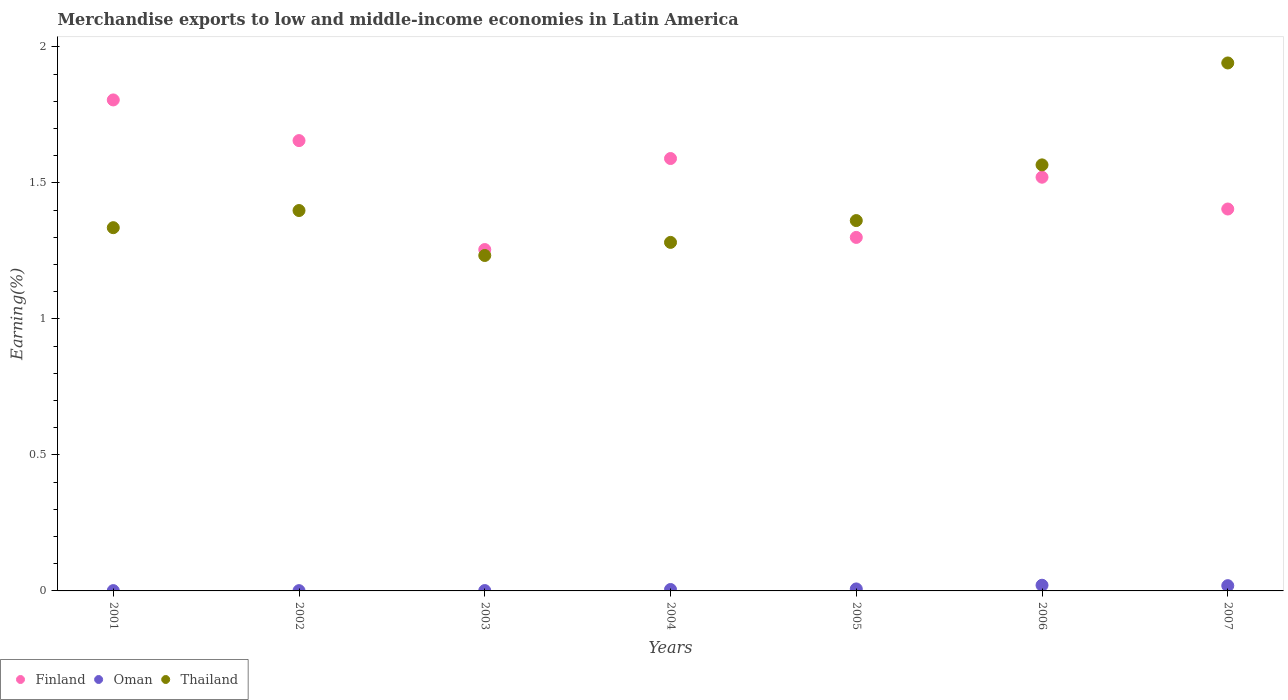How many different coloured dotlines are there?
Your answer should be very brief. 3. Is the number of dotlines equal to the number of legend labels?
Ensure brevity in your answer.  Yes. What is the percentage of amount earned from merchandise exports in Thailand in 2005?
Offer a terse response. 1.36. Across all years, what is the maximum percentage of amount earned from merchandise exports in Oman?
Offer a very short reply. 0.02. Across all years, what is the minimum percentage of amount earned from merchandise exports in Oman?
Offer a very short reply. 0. In which year was the percentage of amount earned from merchandise exports in Finland minimum?
Provide a succinct answer. 2003. What is the total percentage of amount earned from merchandise exports in Oman in the graph?
Your answer should be compact. 0.06. What is the difference between the percentage of amount earned from merchandise exports in Oman in 2002 and that in 2003?
Keep it short and to the point. -0. What is the difference between the percentage of amount earned from merchandise exports in Finland in 2006 and the percentage of amount earned from merchandise exports in Thailand in 2003?
Offer a very short reply. 0.29. What is the average percentage of amount earned from merchandise exports in Thailand per year?
Offer a terse response. 1.45. In the year 2001, what is the difference between the percentage of amount earned from merchandise exports in Thailand and percentage of amount earned from merchandise exports in Oman?
Make the answer very short. 1.33. What is the ratio of the percentage of amount earned from merchandise exports in Finland in 2001 to that in 2006?
Offer a very short reply. 1.19. What is the difference between the highest and the second highest percentage of amount earned from merchandise exports in Oman?
Give a very brief answer. 0. What is the difference between the highest and the lowest percentage of amount earned from merchandise exports in Thailand?
Your response must be concise. 0.71. Is it the case that in every year, the sum of the percentage of amount earned from merchandise exports in Oman and percentage of amount earned from merchandise exports in Finland  is greater than the percentage of amount earned from merchandise exports in Thailand?
Your response must be concise. No. How many dotlines are there?
Give a very brief answer. 3. How many years are there in the graph?
Give a very brief answer. 7. Does the graph contain any zero values?
Make the answer very short. No. How many legend labels are there?
Your response must be concise. 3. What is the title of the graph?
Keep it short and to the point. Merchandise exports to low and middle-income economies in Latin America. Does "United Kingdom" appear as one of the legend labels in the graph?
Make the answer very short. No. What is the label or title of the Y-axis?
Keep it short and to the point. Earning(%). What is the Earning(%) in Finland in 2001?
Ensure brevity in your answer.  1.8. What is the Earning(%) of Oman in 2001?
Offer a terse response. 0. What is the Earning(%) of Thailand in 2001?
Your answer should be compact. 1.34. What is the Earning(%) in Finland in 2002?
Provide a short and direct response. 1.66. What is the Earning(%) of Oman in 2002?
Offer a terse response. 0. What is the Earning(%) in Thailand in 2002?
Offer a terse response. 1.4. What is the Earning(%) in Finland in 2003?
Provide a short and direct response. 1.25. What is the Earning(%) of Oman in 2003?
Ensure brevity in your answer.  0. What is the Earning(%) in Thailand in 2003?
Offer a very short reply. 1.23. What is the Earning(%) of Finland in 2004?
Your answer should be compact. 1.59. What is the Earning(%) in Oman in 2004?
Your answer should be very brief. 0.01. What is the Earning(%) of Thailand in 2004?
Your response must be concise. 1.28. What is the Earning(%) in Finland in 2005?
Keep it short and to the point. 1.3. What is the Earning(%) in Oman in 2005?
Give a very brief answer. 0.01. What is the Earning(%) of Thailand in 2005?
Your answer should be compact. 1.36. What is the Earning(%) in Finland in 2006?
Offer a very short reply. 1.52. What is the Earning(%) in Oman in 2006?
Your response must be concise. 0.02. What is the Earning(%) of Thailand in 2006?
Offer a very short reply. 1.57. What is the Earning(%) in Finland in 2007?
Provide a short and direct response. 1.4. What is the Earning(%) of Oman in 2007?
Ensure brevity in your answer.  0.02. What is the Earning(%) of Thailand in 2007?
Your response must be concise. 1.94. Across all years, what is the maximum Earning(%) in Finland?
Offer a terse response. 1.8. Across all years, what is the maximum Earning(%) in Oman?
Make the answer very short. 0.02. Across all years, what is the maximum Earning(%) in Thailand?
Provide a succinct answer. 1.94. Across all years, what is the minimum Earning(%) of Finland?
Make the answer very short. 1.25. Across all years, what is the minimum Earning(%) in Oman?
Your response must be concise. 0. Across all years, what is the minimum Earning(%) of Thailand?
Keep it short and to the point. 1.23. What is the total Earning(%) of Finland in the graph?
Your answer should be compact. 10.53. What is the total Earning(%) in Oman in the graph?
Your answer should be very brief. 0.06. What is the total Earning(%) of Thailand in the graph?
Provide a short and direct response. 10.12. What is the difference between the Earning(%) in Finland in 2001 and that in 2002?
Offer a terse response. 0.15. What is the difference between the Earning(%) in Thailand in 2001 and that in 2002?
Provide a short and direct response. -0.06. What is the difference between the Earning(%) of Finland in 2001 and that in 2003?
Give a very brief answer. 0.55. What is the difference between the Earning(%) of Oman in 2001 and that in 2003?
Your response must be concise. -0. What is the difference between the Earning(%) of Thailand in 2001 and that in 2003?
Provide a short and direct response. 0.1. What is the difference between the Earning(%) of Finland in 2001 and that in 2004?
Your answer should be very brief. 0.22. What is the difference between the Earning(%) in Oman in 2001 and that in 2004?
Your answer should be very brief. -0. What is the difference between the Earning(%) of Thailand in 2001 and that in 2004?
Keep it short and to the point. 0.05. What is the difference between the Earning(%) in Finland in 2001 and that in 2005?
Offer a terse response. 0.51. What is the difference between the Earning(%) of Oman in 2001 and that in 2005?
Provide a succinct answer. -0.01. What is the difference between the Earning(%) of Thailand in 2001 and that in 2005?
Provide a succinct answer. -0.03. What is the difference between the Earning(%) of Finland in 2001 and that in 2006?
Your response must be concise. 0.28. What is the difference between the Earning(%) of Oman in 2001 and that in 2006?
Your answer should be very brief. -0.02. What is the difference between the Earning(%) of Thailand in 2001 and that in 2006?
Your answer should be very brief. -0.23. What is the difference between the Earning(%) of Finland in 2001 and that in 2007?
Ensure brevity in your answer.  0.4. What is the difference between the Earning(%) of Oman in 2001 and that in 2007?
Ensure brevity in your answer.  -0.02. What is the difference between the Earning(%) in Thailand in 2001 and that in 2007?
Give a very brief answer. -0.61. What is the difference between the Earning(%) in Finland in 2002 and that in 2003?
Your response must be concise. 0.4. What is the difference between the Earning(%) of Oman in 2002 and that in 2003?
Make the answer very short. -0. What is the difference between the Earning(%) in Thailand in 2002 and that in 2003?
Provide a succinct answer. 0.17. What is the difference between the Earning(%) in Finland in 2002 and that in 2004?
Your answer should be compact. 0.07. What is the difference between the Earning(%) of Oman in 2002 and that in 2004?
Provide a short and direct response. -0. What is the difference between the Earning(%) of Thailand in 2002 and that in 2004?
Offer a very short reply. 0.12. What is the difference between the Earning(%) in Finland in 2002 and that in 2005?
Your response must be concise. 0.36. What is the difference between the Earning(%) of Oman in 2002 and that in 2005?
Offer a very short reply. -0.01. What is the difference between the Earning(%) of Thailand in 2002 and that in 2005?
Your answer should be compact. 0.04. What is the difference between the Earning(%) of Finland in 2002 and that in 2006?
Ensure brevity in your answer.  0.13. What is the difference between the Earning(%) in Oman in 2002 and that in 2006?
Offer a terse response. -0.02. What is the difference between the Earning(%) of Thailand in 2002 and that in 2006?
Offer a very short reply. -0.17. What is the difference between the Earning(%) of Finland in 2002 and that in 2007?
Offer a very short reply. 0.25. What is the difference between the Earning(%) of Oman in 2002 and that in 2007?
Ensure brevity in your answer.  -0.02. What is the difference between the Earning(%) of Thailand in 2002 and that in 2007?
Offer a very short reply. -0.54. What is the difference between the Earning(%) in Finland in 2003 and that in 2004?
Ensure brevity in your answer.  -0.33. What is the difference between the Earning(%) of Oman in 2003 and that in 2004?
Your answer should be compact. -0. What is the difference between the Earning(%) in Thailand in 2003 and that in 2004?
Your answer should be compact. -0.05. What is the difference between the Earning(%) in Finland in 2003 and that in 2005?
Ensure brevity in your answer.  -0.04. What is the difference between the Earning(%) of Oman in 2003 and that in 2005?
Your answer should be compact. -0.01. What is the difference between the Earning(%) in Thailand in 2003 and that in 2005?
Give a very brief answer. -0.13. What is the difference between the Earning(%) in Finland in 2003 and that in 2006?
Keep it short and to the point. -0.27. What is the difference between the Earning(%) of Oman in 2003 and that in 2006?
Your answer should be compact. -0.02. What is the difference between the Earning(%) of Thailand in 2003 and that in 2006?
Provide a succinct answer. -0.33. What is the difference between the Earning(%) of Finland in 2003 and that in 2007?
Keep it short and to the point. -0.15. What is the difference between the Earning(%) in Oman in 2003 and that in 2007?
Your answer should be compact. -0.02. What is the difference between the Earning(%) in Thailand in 2003 and that in 2007?
Offer a terse response. -0.71. What is the difference between the Earning(%) of Finland in 2004 and that in 2005?
Your answer should be compact. 0.29. What is the difference between the Earning(%) in Oman in 2004 and that in 2005?
Offer a terse response. -0. What is the difference between the Earning(%) in Thailand in 2004 and that in 2005?
Your response must be concise. -0.08. What is the difference between the Earning(%) of Finland in 2004 and that in 2006?
Provide a short and direct response. 0.07. What is the difference between the Earning(%) in Oman in 2004 and that in 2006?
Your response must be concise. -0.02. What is the difference between the Earning(%) of Thailand in 2004 and that in 2006?
Offer a terse response. -0.28. What is the difference between the Earning(%) of Finland in 2004 and that in 2007?
Your answer should be compact. 0.19. What is the difference between the Earning(%) of Oman in 2004 and that in 2007?
Provide a short and direct response. -0.01. What is the difference between the Earning(%) in Thailand in 2004 and that in 2007?
Your answer should be very brief. -0.66. What is the difference between the Earning(%) in Finland in 2005 and that in 2006?
Give a very brief answer. -0.22. What is the difference between the Earning(%) in Oman in 2005 and that in 2006?
Ensure brevity in your answer.  -0.01. What is the difference between the Earning(%) of Thailand in 2005 and that in 2006?
Ensure brevity in your answer.  -0.2. What is the difference between the Earning(%) of Finland in 2005 and that in 2007?
Give a very brief answer. -0.1. What is the difference between the Earning(%) of Oman in 2005 and that in 2007?
Offer a terse response. -0.01. What is the difference between the Earning(%) of Thailand in 2005 and that in 2007?
Offer a very short reply. -0.58. What is the difference between the Earning(%) of Finland in 2006 and that in 2007?
Offer a very short reply. 0.12. What is the difference between the Earning(%) in Oman in 2006 and that in 2007?
Offer a terse response. 0. What is the difference between the Earning(%) of Thailand in 2006 and that in 2007?
Provide a succinct answer. -0.37. What is the difference between the Earning(%) of Finland in 2001 and the Earning(%) of Oman in 2002?
Your response must be concise. 1.8. What is the difference between the Earning(%) in Finland in 2001 and the Earning(%) in Thailand in 2002?
Give a very brief answer. 0.41. What is the difference between the Earning(%) of Oman in 2001 and the Earning(%) of Thailand in 2002?
Your response must be concise. -1.4. What is the difference between the Earning(%) in Finland in 2001 and the Earning(%) in Oman in 2003?
Keep it short and to the point. 1.8. What is the difference between the Earning(%) in Finland in 2001 and the Earning(%) in Thailand in 2003?
Offer a terse response. 0.57. What is the difference between the Earning(%) in Oman in 2001 and the Earning(%) in Thailand in 2003?
Keep it short and to the point. -1.23. What is the difference between the Earning(%) of Finland in 2001 and the Earning(%) of Oman in 2004?
Offer a very short reply. 1.8. What is the difference between the Earning(%) of Finland in 2001 and the Earning(%) of Thailand in 2004?
Ensure brevity in your answer.  0.52. What is the difference between the Earning(%) of Oman in 2001 and the Earning(%) of Thailand in 2004?
Your answer should be compact. -1.28. What is the difference between the Earning(%) of Finland in 2001 and the Earning(%) of Oman in 2005?
Your answer should be compact. 1.8. What is the difference between the Earning(%) in Finland in 2001 and the Earning(%) in Thailand in 2005?
Give a very brief answer. 0.44. What is the difference between the Earning(%) in Oman in 2001 and the Earning(%) in Thailand in 2005?
Offer a very short reply. -1.36. What is the difference between the Earning(%) in Finland in 2001 and the Earning(%) in Oman in 2006?
Keep it short and to the point. 1.78. What is the difference between the Earning(%) of Finland in 2001 and the Earning(%) of Thailand in 2006?
Keep it short and to the point. 0.24. What is the difference between the Earning(%) in Oman in 2001 and the Earning(%) in Thailand in 2006?
Ensure brevity in your answer.  -1.56. What is the difference between the Earning(%) in Finland in 2001 and the Earning(%) in Oman in 2007?
Your response must be concise. 1.79. What is the difference between the Earning(%) of Finland in 2001 and the Earning(%) of Thailand in 2007?
Ensure brevity in your answer.  -0.14. What is the difference between the Earning(%) in Oman in 2001 and the Earning(%) in Thailand in 2007?
Offer a very short reply. -1.94. What is the difference between the Earning(%) of Finland in 2002 and the Earning(%) of Oman in 2003?
Offer a very short reply. 1.65. What is the difference between the Earning(%) of Finland in 2002 and the Earning(%) of Thailand in 2003?
Your answer should be compact. 0.42. What is the difference between the Earning(%) in Oman in 2002 and the Earning(%) in Thailand in 2003?
Offer a terse response. -1.23. What is the difference between the Earning(%) of Finland in 2002 and the Earning(%) of Oman in 2004?
Your answer should be very brief. 1.65. What is the difference between the Earning(%) of Finland in 2002 and the Earning(%) of Thailand in 2004?
Offer a very short reply. 0.37. What is the difference between the Earning(%) in Oman in 2002 and the Earning(%) in Thailand in 2004?
Offer a terse response. -1.28. What is the difference between the Earning(%) of Finland in 2002 and the Earning(%) of Oman in 2005?
Give a very brief answer. 1.65. What is the difference between the Earning(%) of Finland in 2002 and the Earning(%) of Thailand in 2005?
Offer a terse response. 0.29. What is the difference between the Earning(%) of Oman in 2002 and the Earning(%) of Thailand in 2005?
Your answer should be compact. -1.36. What is the difference between the Earning(%) in Finland in 2002 and the Earning(%) in Oman in 2006?
Provide a short and direct response. 1.63. What is the difference between the Earning(%) in Finland in 2002 and the Earning(%) in Thailand in 2006?
Your response must be concise. 0.09. What is the difference between the Earning(%) of Oman in 2002 and the Earning(%) of Thailand in 2006?
Your response must be concise. -1.56. What is the difference between the Earning(%) in Finland in 2002 and the Earning(%) in Oman in 2007?
Your answer should be compact. 1.64. What is the difference between the Earning(%) of Finland in 2002 and the Earning(%) of Thailand in 2007?
Ensure brevity in your answer.  -0.29. What is the difference between the Earning(%) of Oman in 2002 and the Earning(%) of Thailand in 2007?
Ensure brevity in your answer.  -1.94. What is the difference between the Earning(%) in Finland in 2003 and the Earning(%) in Oman in 2004?
Your response must be concise. 1.25. What is the difference between the Earning(%) of Finland in 2003 and the Earning(%) of Thailand in 2004?
Provide a succinct answer. -0.03. What is the difference between the Earning(%) of Oman in 2003 and the Earning(%) of Thailand in 2004?
Keep it short and to the point. -1.28. What is the difference between the Earning(%) of Finland in 2003 and the Earning(%) of Oman in 2005?
Your response must be concise. 1.25. What is the difference between the Earning(%) in Finland in 2003 and the Earning(%) in Thailand in 2005?
Give a very brief answer. -0.11. What is the difference between the Earning(%) in Oman in 2003 and the Earning(%) in Thailand in 2005?
Make the answer very short. -1.36. What is the difference between the Earning(%) in Finland in 2003 and the Earning(%) in Oman in 2006?
Give a very brief answer. 1.23. What is the difference between the Earning(%) of Finland in 2003 and the Earning(%) of Thailand in 2006?
Keep it short and to the point. -0.31. What is the difference between the Earning(%) of Oman in 2003 and the Earning(%) of Thailand in 2006?
Give a very brief answer. -1.56. What is the difference between the Earning(%) of Finland in 2003 and the Earning(%) of Oman in 2007?
Keep it short and to the point. 1.24. What is the difference between the Earning(%) of Finland in 2003 and the Earning(%) of Thailand in 2007?
Your response must be concise. -0.69. What is the difference between the Earning(%) of Oman in 2003 and the Earning(%) of Thailand in 2007?
Your answer should be very brief. -1.94. What is the difference between the Earning(%) in Finland in 2004 and the Earning(%) in Oman in 2005?
Offer a very short reply. 1.58. What is the difference between the Earning(%) in Finland in 2004 and the Earning(%) in Thailand in 2005?
Your answer should be compact. 0.23. What is the difference between the Earning(%) of Oman in 2004 and the Earning(%) of Thailand in 2005?
Your answer should be very brief. -1.36. What is the difference between the Earning(%) of Finland in 2004 and the Earning(%) of Oman in 2006?
Offer a terse response. 1.57. What is the difference between the Earning(%) in Finland in 2004 and the Earning(%) in Thailand in 2006?
Your answer should be very brief. 0.02. What is the difference between the Earning(%) in Oman in 2004 and the Earning(%) in Thailand in 2006?
Your answer should be compact. -1.56. What is the difference between the Earning(%) of Finland in 2004 and the Earning(%) of Oman in 2007?
Offer a very short reply. 1.57. What is the difference between the Earning(%) of Finland in 2004 and the Earning(%) of Thailand in 2007?
Offer a terse response. -0.35. What is the difference between the Earning(%) in Oman in 2004 and the Earning(%) in Thailand in 2007?
Your response must be concise. -1.94. What is the difference between the Earning(%) in Finland in 2005 and the Earning(%) in Oman in 2006?
Give a very brief answer. 1.28. What is the difference between the Earning(%) of Finland in 2005 and the Earning(%) of Thailand in 2006?
Give a very brief answer. -0.27. What is the difference between the Earning(%) in Oman in 2005 and the Earning(%) in Thailand in 2006?
Make the answer very short. -1.56. What is the difference between the Earning(%) in Finland in 2005 and the Earning(%) in Oman in 2007?
Provide a succinct answer. 1.28. What is the difference between the Earning(%) of Finland in 2005 and the Earning(%) of Thailand in 2007?
Offer a very short reply. -0.64. What is the difference between the Earning(%) in Oman in 2005 and the Earning(%) in Thailand in 2007?
Keep it short and to the point. -1.93. What is the difference between the Earning(%) of Finland in 2006 and the Earning(%) of Oman in 2007?
Keep it short and to the point. 1.5. What is the difference between the Earning(%) in Finland in 2006 and the Earning(%) in Thailand in 2007?
Keep it short and to the point. -0.42. What is the difference between the Earning(%) in Oman in 2006 and the Earning(%) in Thailand in 2007?
Ensure brevity in your answer.  -1.92. What is the average Earning(%) of Finland per year?
Your response must be concise. 1.5. What is the average Earning(%) in Oman per year?
Provide a short and direct response. 0.01. What is the average Earning(%) in Thailand per year?
Provide a succinct answer. 1.45. In the year 2001, what is the difference between the Earning(%) of Finland and Earning(%) of Oman?
Offer a very short reply. 1.8. In the year 2001, what is the difference between the Earning(%) of Finland and Earning(%) of Thailand?
Your answer should be compact. 0.47. In the year 2001, what is the difference between the Earning(%) in Oman and Earning(%) in Thailand?
Offer a terse response. -1.33. In the year 2002, what is the difference between the Earning(%) of Finland and Earning(%) of Oman?
Your answer should be very brief. 1.65. In the year 2002, what is the difference between the Earning(%) of Finland and Earning(%) of Thailand?
Your answer should be compact. 0.26. In the year 2002, what is the difference between the Earning(%) of Oman and Earning(%) of Thailand?
Your response must be concise. -1.4. In the year 2003, what is the difference between the Earning(%) of Finland and Earning(%) of Oman?
Offer a terse response. 1.25. In the year 2003, what is the difference between the Earning(%) in Finland and Earning(%) in Thailand?
Your response must be concise. 0.02. In the year 2003, what is the difference between the Earning(%) of Oman and Earning(%) of Thailand?
Your response must be concise. -1.23. In the year 2004, what is the difference between the Earning(%) in Finland and Earning(%) in Oman?
Ensure brevity in your answer.  1.58. In the year 2004, what is the difference between the Earning(%) of Finland and Earning(%) of Thailand?
Offer a terse response. 0.31. In the year 2004, what is the difference between the Earning(%) of Oman and Earning(%) of Thailand?
Give a very brief answer. -1.28. In the year 2005, what is the difference between the Earning(%) in Finland and Earning(%) in Oman?
Keep it short and to the point. 1.29. In the year 2005, what is the difference between the Earning(%) of Finland and Earning(%) of Thailand?
Your answer should be very brief. -0.06. In the year 2005, what is the difference between the Earning(%) in Oman and Earning(%) in Thailand?
Provide a succinct answer. -1.35. In the year 2006, what is the difference between the Earning(%) of Finland and Earning(%) of Oman?
Your answer should be very brief. 1.5. In the year 2006, what is the difference between the Earning(%) of Finland and Earning(%) of Thailand?
Your response must be concise. -0.05. In the year 2006, what is the difference between the Earning(%) in Oman and Earning(%) in Thailand?
Your response must be concise. -1.55. In the year 2007, what is the difference between the Earning(%) in Finland and Earning(%) in Oman?
Provide a short and direct response. 1.38. In the year 2007, what is the difference between the Earning(%) in Finland and Earning(%) in Thailand?
Your answer should be very brief. -0.54. In the year 2007, what is the difference between the Earning(%) in Oman and Earning(%) in Thailand?
Ensure brevity in your answer.  -1.92. What is the ratio of the Earning(%) of Finland in 2001 to that in 2002?
Offer a very short reply. 1.09. What is the ratio of the Earning(%) in Oman in 2001 to that in 2002?
Ensure brevity in your answer.  1.06. What is the ratio of the Earning(%) of Thailand in 2001 to that in 2002?
Make the answer very short. 0.95. What is the ratio of the Earning(%) in Finland in 2001 to that in 2003?
Make the answer very short. 1.44. What is the ratio of the Earning(%) of Oman in 2001 to that in 2003?
Keep it short and to the point. 0.84. What is the ratio of the Earning(%) in Thailand in 2001 to that in 2003?
Provide a short and direct response. 1.08. What is the ratio of the Earning(%) of Finland in 2001 to that in 2004?
Your response must be concise. 1.14. What is the ratio of the Earning(%) of Oman in 2001 to that in 2004?
Keep it short and to the point. 0.21. What is the ratio of the Earning(%) of Thailand in 2001 to that in 2004?
Provide a short and direct response. 1.04. What is the ratio of the Earning(%) of Finland in 2001 to that in 2005?
Ensure brevity in your answer.  1.39. What is the ratio of the Earning(%) of Oman in 2001 to that in 2005?
Offer a very short reply. 0.15. What is the ratio of the Earning(%) in Thailand in 2001 to that in 2005?
Offer a terse response. 0.98. What is the ratio of the Earning(%) of Finland in 2001 to that in 2006?
Provide a short and direct response. 1.19. What is the ratio of the Earning(%) of Oman in 2001 to that in 2006?
Give a very brief answer. 0.05. What is the ratio of the Earning(%) in Thailand in 2001 to that in 2006?
Give a very brief answer. 0.85. What is the ratio of the Earning(%) of Finland in 2001 to that in 2007?
Keep it short and to the point. 1.29. What is the ratio of the Earning(%) in Oman in 2001 to that in 2007?
Offer a very short reply. 0.06. What is the ratio of the Earning(%) in Thailand in 2001 to that in 2007?
Your answer should be compact. 0.69. What is the ratio of the Earning(%) of Finland in 2002 to that in 2003?
Offer a very short reply. 1.32. What is the ratio of the Earning(%) in Oman in 2002 to that in 2003?
Your response must be concise. 0.79. What is the ratio of the Earning(%) of Thailand in 2002 to that in 2003?
Provide a succinct answer. 1.13. What is the ratio of the Earning(%) of Finland in 2002 to that in 2004?
Provide a succinct answer. 1.04. What is the ratio of the Earning(%) of Thailand in 2002 to that in 2004?
Keep it short and to the point. 1.09. What is the ratio of the Earning(%) of Finland in 2002 to that in 2005?
Keep it short and to the point. 1.27. What is the ratio of the Earning(%) of Oman in 2002 to that in 2005?
Keep it short and to the point. 0.14. What is the ratio of the Earning(%) in Thailand in 2002 to that in 2005?
Give a very brief answer. 1.03. What is the ratio of the Earning(%) in Finland in 2002 to that in 2006?
Provide a succinct answer. 1.09. What is the ratio of the Earning(%) of Oman in 2002 to that in 2006?
Give a very brief answer. 0.05. What is the ratio of the Earning(%) in Thailand in 2002 to that in 2006?
Your response must be concise. 0.89. What is the ratio of the Earning(%) of Finland in 2002 to that in 2007?
Ensure brevity in your answer.  1.18. What is the ratio of the Earning(%) of Oman in 2002 to that in 2007?
Make the answer very short. 0.05. What is the ratio of the Earning(%) in Thailand in 2002 to that in 2007?
Keep it short and to the point. 0.72. What is the ratio of the Earning(%) of Finland in 2003 to that in 2004?
Ensure brevity in your answer.  0.79. What is the ratio of the Earning(%) in Oman in 2003 to that in 2004?
Ensure brevity in your answer.  0.25. What is the ratio of the Earning(%) of Thailand in 2003 to that in 2004?
Keep it short and to the point. 0.96. What is the ratio of the Earning(%) in Finland in 2003 to that in 2005?
Offer a very short reply. 0.97. What is the ratio of the Earning(%) in Oman in 2003 to that in 2005?
Offer a very short reply. 0.18. What is the ratio of the Earning(%) in Thailand in 2003 to that in 2005?
Provide a succinct answer. 0.91. What is the ratio of the Earning(%) of Finland in 2003 to that in 2006?
Your response must be concise. 0.83. What is the ratio of the Earning(%) of Oman in 2003 to that in 2006?
Your response must be concise. 0.06. What is the ratio of the Earning(%) of Thailand in 2003 to that in 2006?
Your answer should be very brief. 0.79. What is the ratio of the Earning(%) in Finland in 2003 to that in 2007?
Provide a short and direct response. 0.89. What is the ratio of the Earning(%) in Oman in 2003 to that in 2007?
Offer a very short reply. 0.07. What is the ratio of the Earning(%) in Thailand in 2003 to that in 2007?
Your answer should be compact. 0.64. What is the ratio of the Earning(%) of Finland in 2004 to that in 2005?
Make the answer very short. 1.22. What is the ratio of the Earning(%) of Oman in 2004 to that in 2005?
Offer a terse response. 0.71. What is the ratio of the Earning(%) in Thailand in 2004 to that in 2005?
Make the answer very short. 0.94. What is the ratio of the Earning(%) of Finland in 2004 to that in 2006?
Your answer should be very brief. 1.05. What is the ratio of the Earning(%) of Oman in 2004 to that in 2006?
Offer a terse response. 0.25. What is the ratio of the Earning(%) in Thailand in 2004 to that in 2006?
Ensure brevity in your answer.  0.82. What is the ratio of the Earning(%) in Finland in 2004 to that in 2007?
Provide a short and direct response. 1.13. What is the ratio of the Earning(%) in Oman in 2004 to that in 2007?
Provide a short and direct response. 0.27. What is the ratio of the Earning(%) of Thailand in 2004 to that in 2007?
Provide a succinct answer. 0.66. What is the ratio of the Earning(%) of Finland in 2005 to that in 2006?
Your answer should be compact. 0.85. What is the ratio of the Earning(%) of Oman in 2005 to that in 2006?
Make the answer very short. 0.35. What is the ratio of the Earning(%) of Thailand in 2005 to that in 2006?
Your answer should be compact. 0.87. What is the ratio of the Earning(%) of Finland in 2005 to that in 2007?
Offer a terse response. 0.93. What is the ratio of the Earning(%) in Oman in 2005 to that in 2007?
Provide a succinct answer. 0.38. What is the ratio of the Earning(%) in Thailand in 2005 to that in 2007?
Offer a terse response. 0.7. What is the ratio of the Earning(%) of Finland in 2006 to that in 2007?
Offer a terse response. 1.08. What is the ratio of the Earning(%) in Oman in 2006 to that in 2007?
Offer a very short reply. 1.08. What is the ratio of the Earning(%) of Thailand in 2006 to that in 2007?
Your answer should be compact. 0.81. What is the difference between the highest and the second highest Earning(%) in Finland?
Ensure brevity in your answer.  0.15. What is the difference between the highest and the second highest Earning(%) in Oman?
Your answer should be compact. 0. What is the difference between the highest and the second highest Earning(%) in Thailand?
Offer a terse response. 0.37. What is the difference between the highest and the lowest Earning(%) in Finland?
Ensure brevity in your answer.  0.55. What is the difference between the highest and the lowest Earning(%) of Oman?
Your answer should be very brief. 0.02. What is the difference between the highest and the lowest Earning(%) of Thailand?
Provide a short and direct response. 0.71. 